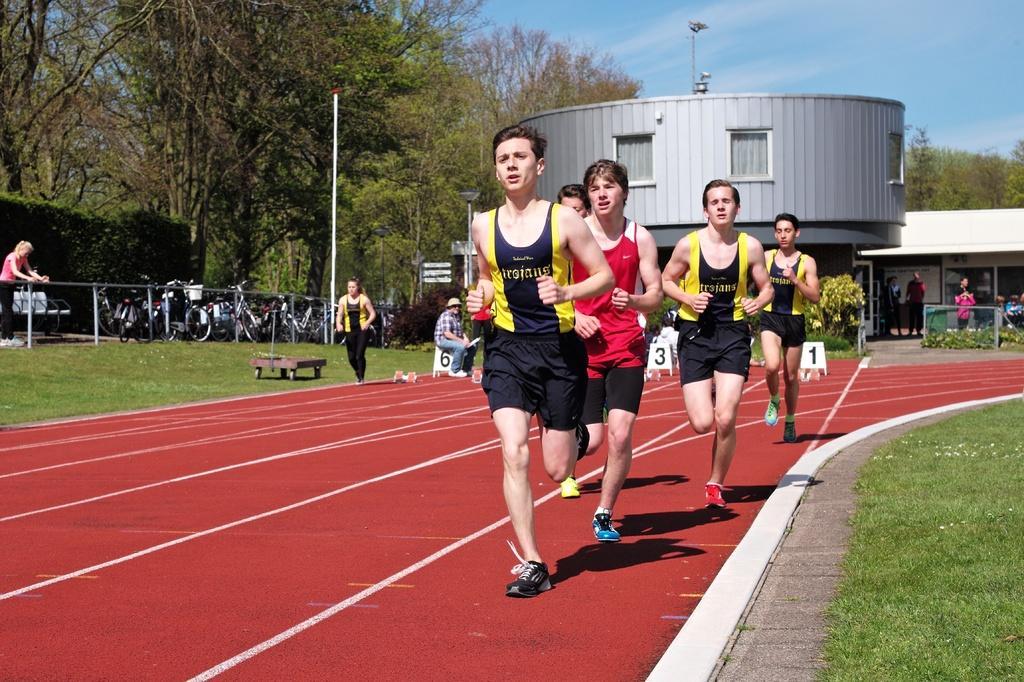Could you give a brief overview of what you see in this image? Here I can see few men are wearing t-shirts, shorts and running on the road. On both sides of the road I can see the green color grass. On the left side two women are standing and a man is sitting on a bench and I can see few vehicles on the road. On the right side there are few people standing and looking at this men. In the background there is a building and some trees. On the top of the image I can see the sky. 